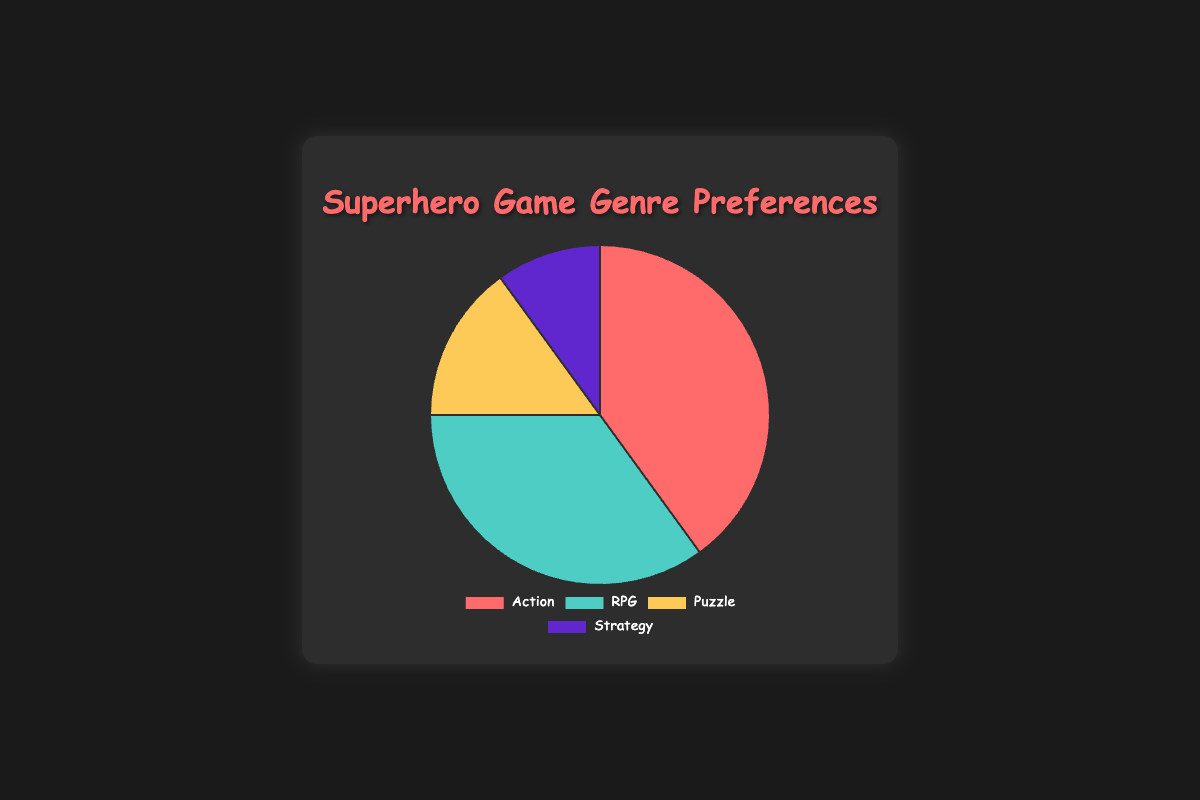What genre has the highest preference among comic book fans? The Action genre has the highest preference with a 40% share, as indicated by the largest slice of the pie chart.
Answer: Action Which genre has the lowest preference? How much is it? The Strategy genre has the lowest preference with a 10% share, as indicated by the smallest slice of the pie chart.
Answer: Strategy, 10% How much higher is the preference for Action games compared to Puzzle games? The preference for Action games (40%) is 25% higher than for Puzzle games (15%). Subtract the Puzzle preference from the Action preference: 40% - 15% = 25%.
Answer: 25% What is the total combined preference percentage for RPG and Strategy genres? Add the preference percentages of RPG (35%) and Strategy (10%) genres: 35% + 10% = 45%.
Answer: 45% By how much does the RPG preference percentage exceed the Strategy preference percentage? The RPG preference (35%) exceeds the Strategy preference (10%) by 25%. Subtract the Strategy preference from the RPG preference: 35% - 10% = 25%.
Answer: 25% What genres make up more than 30% of preferences? Both Action (40%) and RPG (35%) genres make up more than 30% of the preferences.
Answer: Action, RPG Is the combined preference for Puzzle and Strategy lower than the preference for RPG games? Combine the Puzzle (15%) and Strategy (10%) preferences: 15% + 10% = 25%. The combined 25% is lower than the 35% for RPG games.
Answer: Yes Use the colors to identify which genre is represented by the yellow slice. The yellow slice represents the Puzzle genre, which has a 15% preference.
Answer: Puzzle Which genres together make up exactly half of the preferences? The Puzzle (15%) and Strategy (10%) preferences together make up 25%, and Action (40%) and RPG (35%) combined exceed half the preferences. However, Action (40%) and Puzzle (15%) together make up exactly 55%. Therefore, no two genres exactly make up half of the preferences.
Answer: No two genres Between Strategy and Puzzle, which genre has a smaller preference, and by how much? Strategy has a smaller preference at 10%, compared to Puzzle's 15%. The difference is 15% - 10% = 5%.
Answer: Strategy, 5% 